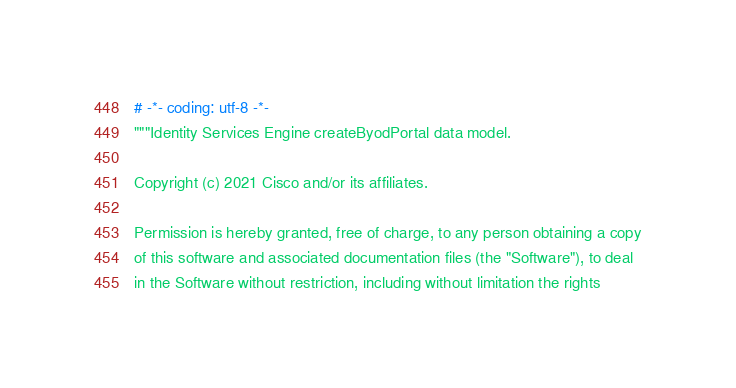Convert code to text. <code><loc_0><loc_0><loc_500><loc_500><_Python_># -*- coding: utf-8 -*-
"""Identity Services Engine createByodPortal data model.

Copyright (c) 2021 Cisco and/or its affiliates.

Permission is hereby granted, free of charge, to any person obtaining a copy
of this software and associated documentation files (the "Software"), to deal
in the Software without restriction, including without limitation the rights</code> 